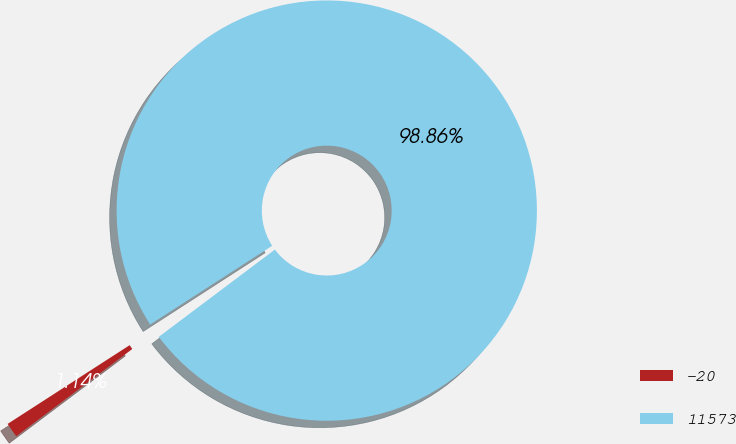Convert chart. <chart><loc_0><loc_0><loc_500><loc_500><pie_chart><fcel>-20<fcel>11573<nl><fcel>1.14%<fcel>98.86%<nl></chart> 